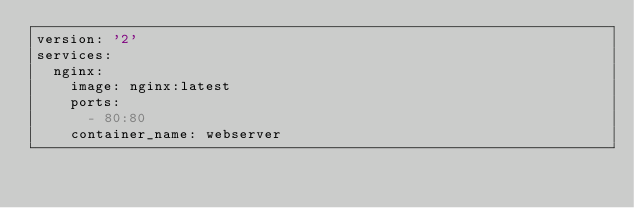<code> <loc_0><loc_0><loc_500><loc_500><_YAML_>version: '2'
services:
  nginx:
    image: nginx:latest
    ports:
      - 80:80
    container_name: webserver
</code> 